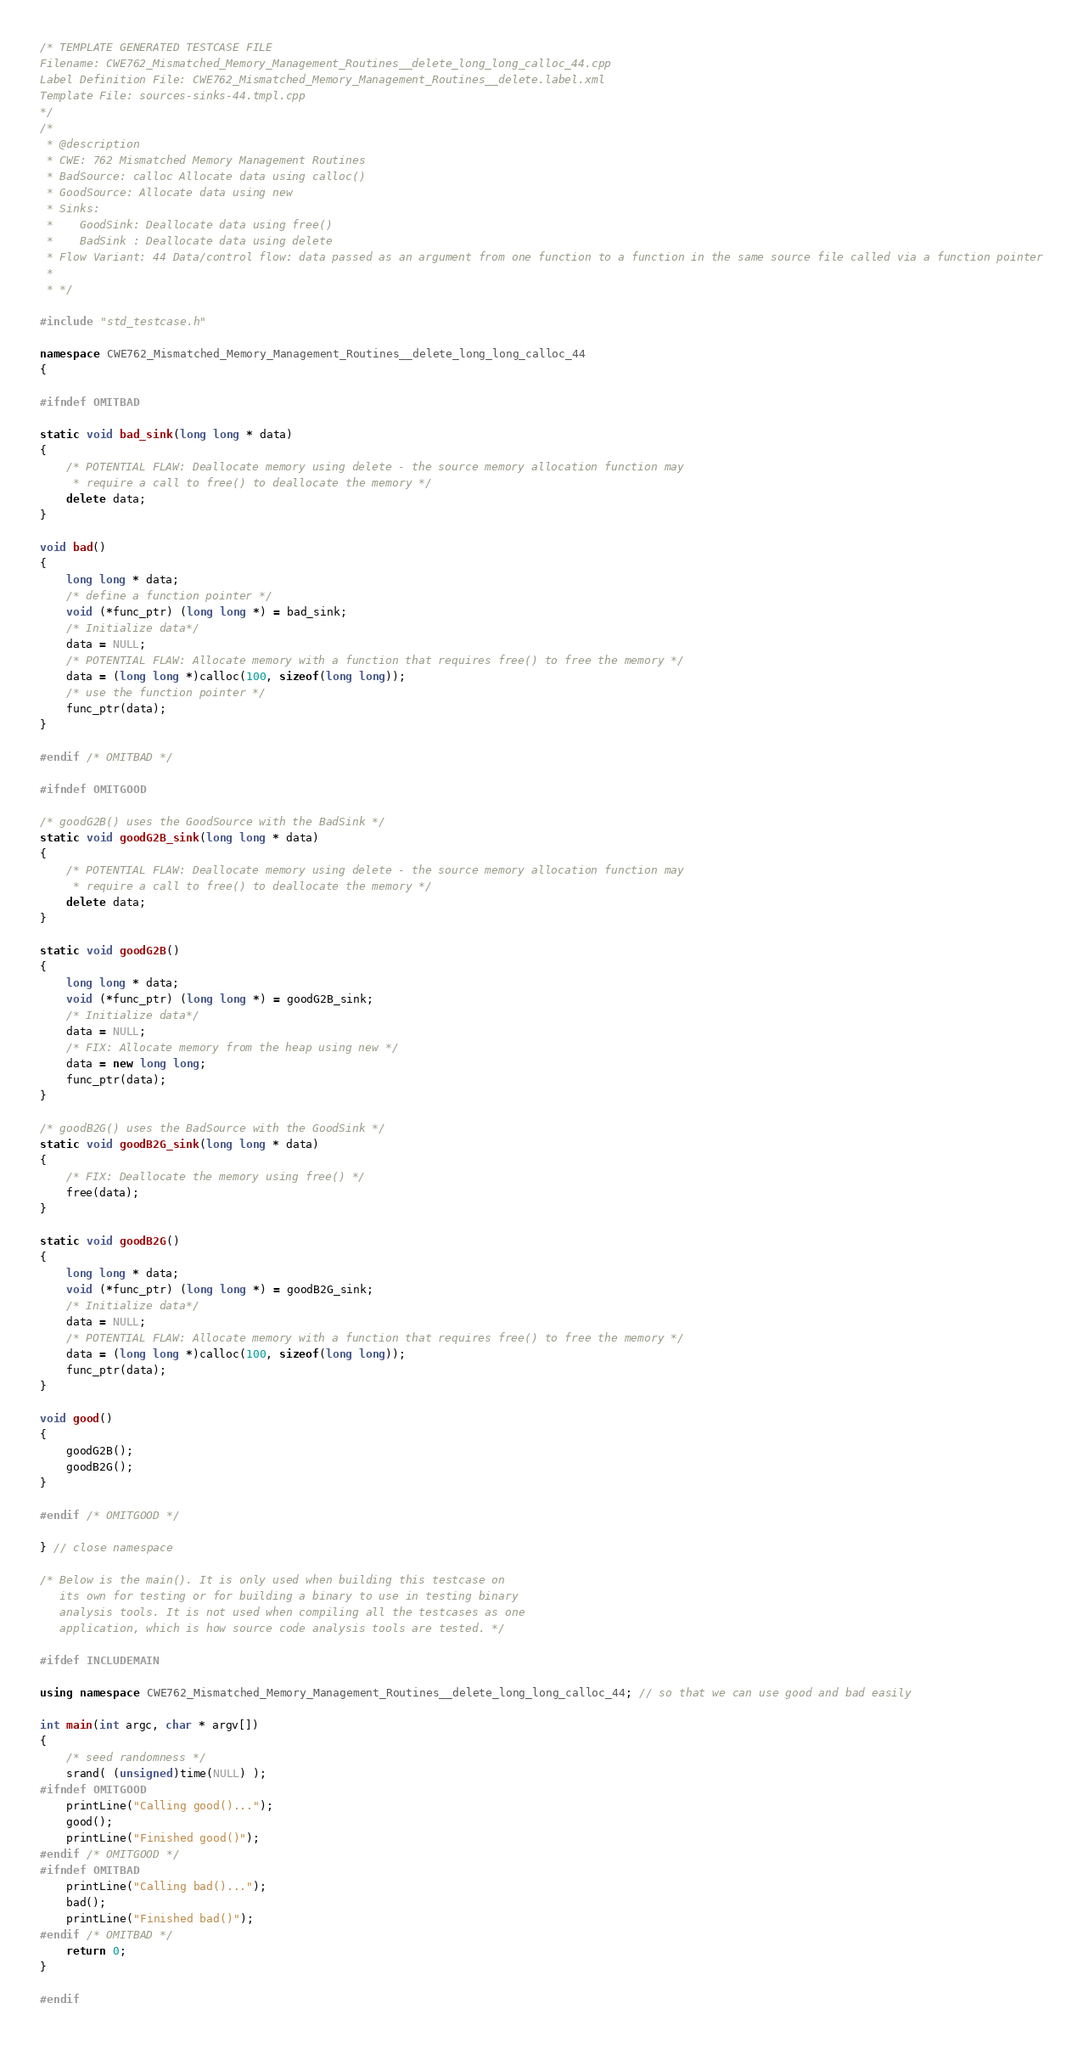Convert code to text. <code><loc_0><loc_0><loc_500><loc_500><_C++_>/* TEMPLATE GENERATED TESTCASE FILE
Filename: CWE762_Mismatched_Memory_Management_Routines__delete_long_long_calloc_44.cpp
Label Definition File: CWE762_Mismatched_Memory_Management_Routines__delete.label.xml
Template File: sources-sinks-44.tmpl.cpp
*/
/*
 * @description
 * CWE: 762 Mismatched Memory Management Routines
 * BadSource: calloc Allocate data using calloc()
 * GoodSource: Allocate data using new
 * Sinks:
 *    GoodSink: Deallocate data using free()
 *    BadSink : Deallocate data using delete
 * Flow Variant: 44 Data/control flow: data passed as an argument from one function to a function in the same source file called via a function pointer
 *
 * */

#include "std_testcase.h"

namespace CWE762_Mismatched_Memory_Management_Routines__delete_long_long_calloc_44
{

#ifndef OMITBAD

static void bad_sink(long long * data)
{
    /* POTENTIAL FLAW: Deallocate memory using delete - the source memory allocation function may
     * require a call to free() to deallocate the memory */
    delete data;
}

void bad()
{
    long long * data;
    /* define a function pointer */
    void (*func_ptr) (long long *) = bad_sink;
    /* Initialize data*/
    data = NULL;
    /* POTENTIAL FLAW: Allocate memory with a function that requires free() to free the memory */
    data = (long long *)calloc(100, sizeof(long long));
    /* use the function pointer */
    func_ptr(data);
}

#endif /* OMITBAD */

#ifndef OMITGOOD

/* goodG2B() uses the GoodSource with the BadSink */
static void goodG2B_sink(long long * data)
{
    /* POTENTIAL FLAW: Deallocate memory using delete - the source memory allocation function may
     * require a call to free() to deallocate the memory */
    delete data;
}

static void goodG2B()
{
    long long * data;
    void (*func_ptr) (long long *) = goodG2B_sink;
    /* Initialize data*/
    data = NULL;
    /* FIX: Allocate memory from the heap using new */
    data = new long long;
    func_ptr(data);
}

/* goodB2G() uses the BadSource with the GoodSink */
static void goodB2G_sink(long long * data)
{
    /* FIX: Deallocate the memory using free() */
    free(data);
}

static void goodB2G()
{
    long long * data;
    void (*func_ptr) (long long *) = goodB2G_sink;
    /* Initialize data*/
    data = NULL;
    /* POTENTIAL FLAW: Allocate memory with a function that requires free() to free the memory */
    data = (long long *)calloc(100, sizeof(long long));
    func_ptr(data);
}

void good()
{
    goodG2B();
    goodB2G();
}

#endif /* OMITGOOD */

} // close namespace

/* Below is the main(). It is only used when building this testcase on
   its own for testing or for building a binary to use in testing binary
   analysis tools. It is not used when compiling all the testcases as one
   application, which is how source code analysis tools are tested. */

#ifdef INCLUDEMAIN

using namespace CWE762_Mismatched_Memory_Management_Routines__delete_long_long_calloc_44; // so that we can use good and bad easily

int main(int argc, char * argv[])
{
    /* seed randomness */
    srand( (unsigned)time(NULL) );
#ifndef OMITGOOD
    printLine("Calling good()...");
    good();
    printLine("Finished good()");
#endif /* OMITGOOD */
#ifndef OMITBAD
    printLine("Calling bad()...");
    bad();
    printLine("Finished bad()");
#endif /* OMITBAD */
    return 0;
}

#endif
</code> 